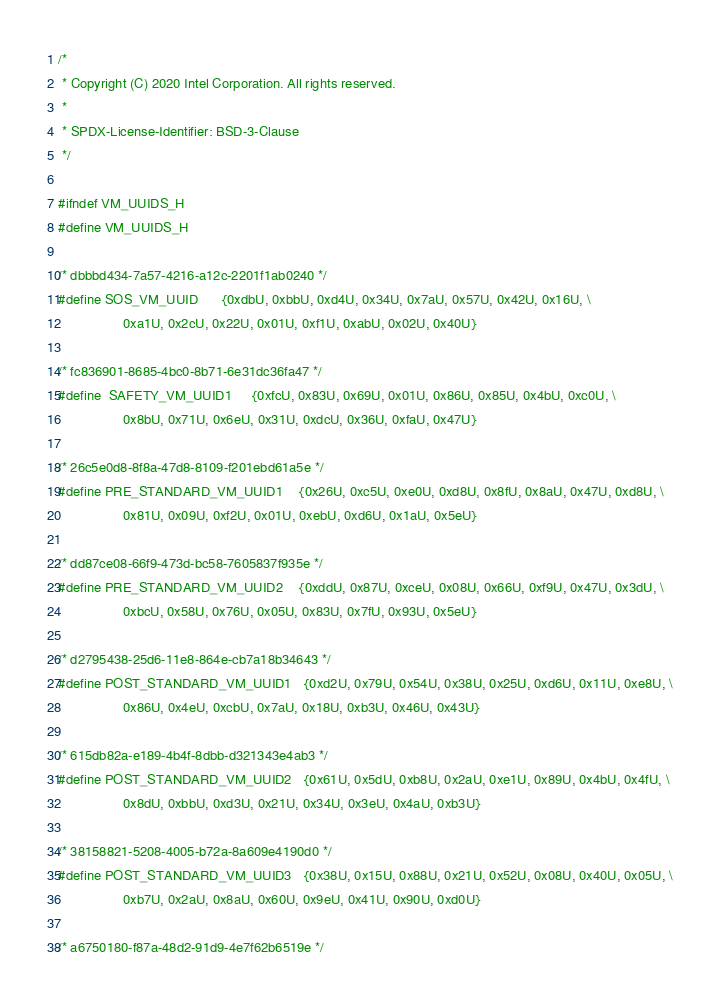Convert code to text. <code><loc_0><loc_0><loc_500><loc_500><_C_>/*
 * Copyright (C) 2020 Intel Corporation. All rights reserved.
 *
 * SPDX-License-Identifier: BSD-3-Clause
 */

#ifndef VM_UUIDS_H
#define VM_UUIDS_H

/* dbbbd434-7a57-4216-a12c-2201f1ab0240 */
#define SOS_VM_UUID		{0xdbU, 0xbbU, 0xd4U, 0x34U, 0x7aU, 0x57U, 0x42U, 0x16U, \
				 0xa1U, 0x2cU, 0x22U, 0x01U, 0xf1U, 0xabU, 0x02U, 0x40U}

/* fc836901-8685-4bc0-8b71-6e31dc36fa47 */
#define	SAFETY_VM_UUID1		{0xfcU, 0x83U, 0x69U, 0x01U, 0x86U, 0x85U, 0x4bU, 0xc0U, \
				 0x8bU, 0x71U, 0x6eU, 0x31U, 0xdcU, 0x36U, 0xfaU, 0x47U}

/* 26c5e0d8-8f8a-47d8-8109-f201ebd61a5e */
#define PRE_STANDARD_VM_UUID1	{0x26U, 0xc5U, 0xe0U, 0xd8U, 0x8fU, 0x8aU, 0x47U, 0xd8U, \
				 0x81U, 0x09U, 0xf2U, 0x01U, 0xebU, 0xd6U, 0x1aU, 0x5eU}

/* dd87ce08-66f9-473d-bc58-7605837f935e */
#define PRE_STANDARD_VM_UUID2	{0xddU, 0x87U, 0xceU, 0x08U, 0x66U, 0xf9U, 0x47U, 0x3dU, \
				 0xbcU, 0x58U, 0x76U, 0x05U, 0x83U, 0x7fU, 0x93U, 0x5eU}

/* d2795438-25d6-11e8-864e-cb7a18b34643 */
#define POST_STANDARD_VM_UUID1	{0xd2U, 0x79U, 0x54U, 0x38U, 0x25U, 0xd6U, 0x11U, 0xe8U, \
				 0x86U, 0x4eU, 0xcbU, 0x7aU, 0x18U, 0xb3U, 0x46U, 0x43U}

/* 615db82a-e189-4b4f-8dbb-d321343e4ab3 */
#define POST_STANDARD_VM_UUID2	{0x61U, 0x5dU, 0xb8U, 0x2aU, 0xe1U, 0x89U, 0x4bU, 0x4fU, \
				 0x8dU, 0xbbU, 0xd3U, 0x21U, 0x34U, 0x3eU, 0x4aU, 0xb3U}

/* 38158821-5208-4005-b72a-8a609e4190d0 */
#define POST_STANDARD_VM_UUID3	{0x38U, 0x15U, 0x88U, 0x21U, 0x52U, 0x08U, 0x40U, 0x05U, \
				 0xb7U, 0x2aU, 0x8aU, 0x60U, 0x9eU, 0x41U, 0x90U, 0xd0U}

/* a6750180-f87a-48d2-91d9-4e7f62b6519e */</code> 